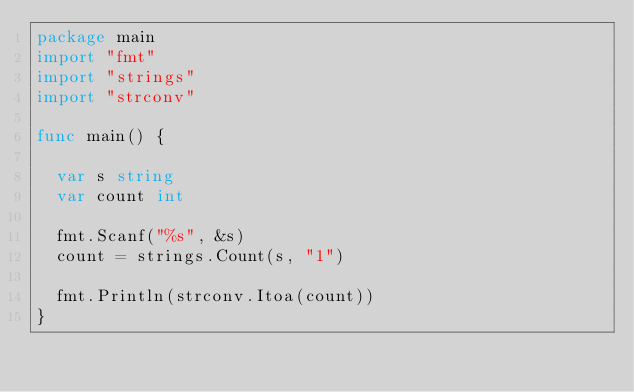<code> <loc_0><loc_0><loc_500><loc_500><_Go_>package main
import "fmt" 
import "strings"
import "strconv"

func main() {
  
  var s string
  var count int
  
  fmt.Scanf("%s", &s)
  count = strings.Count(s, "1")
  
  fmt.Println(strconv.Itoa(count))
}</code> 